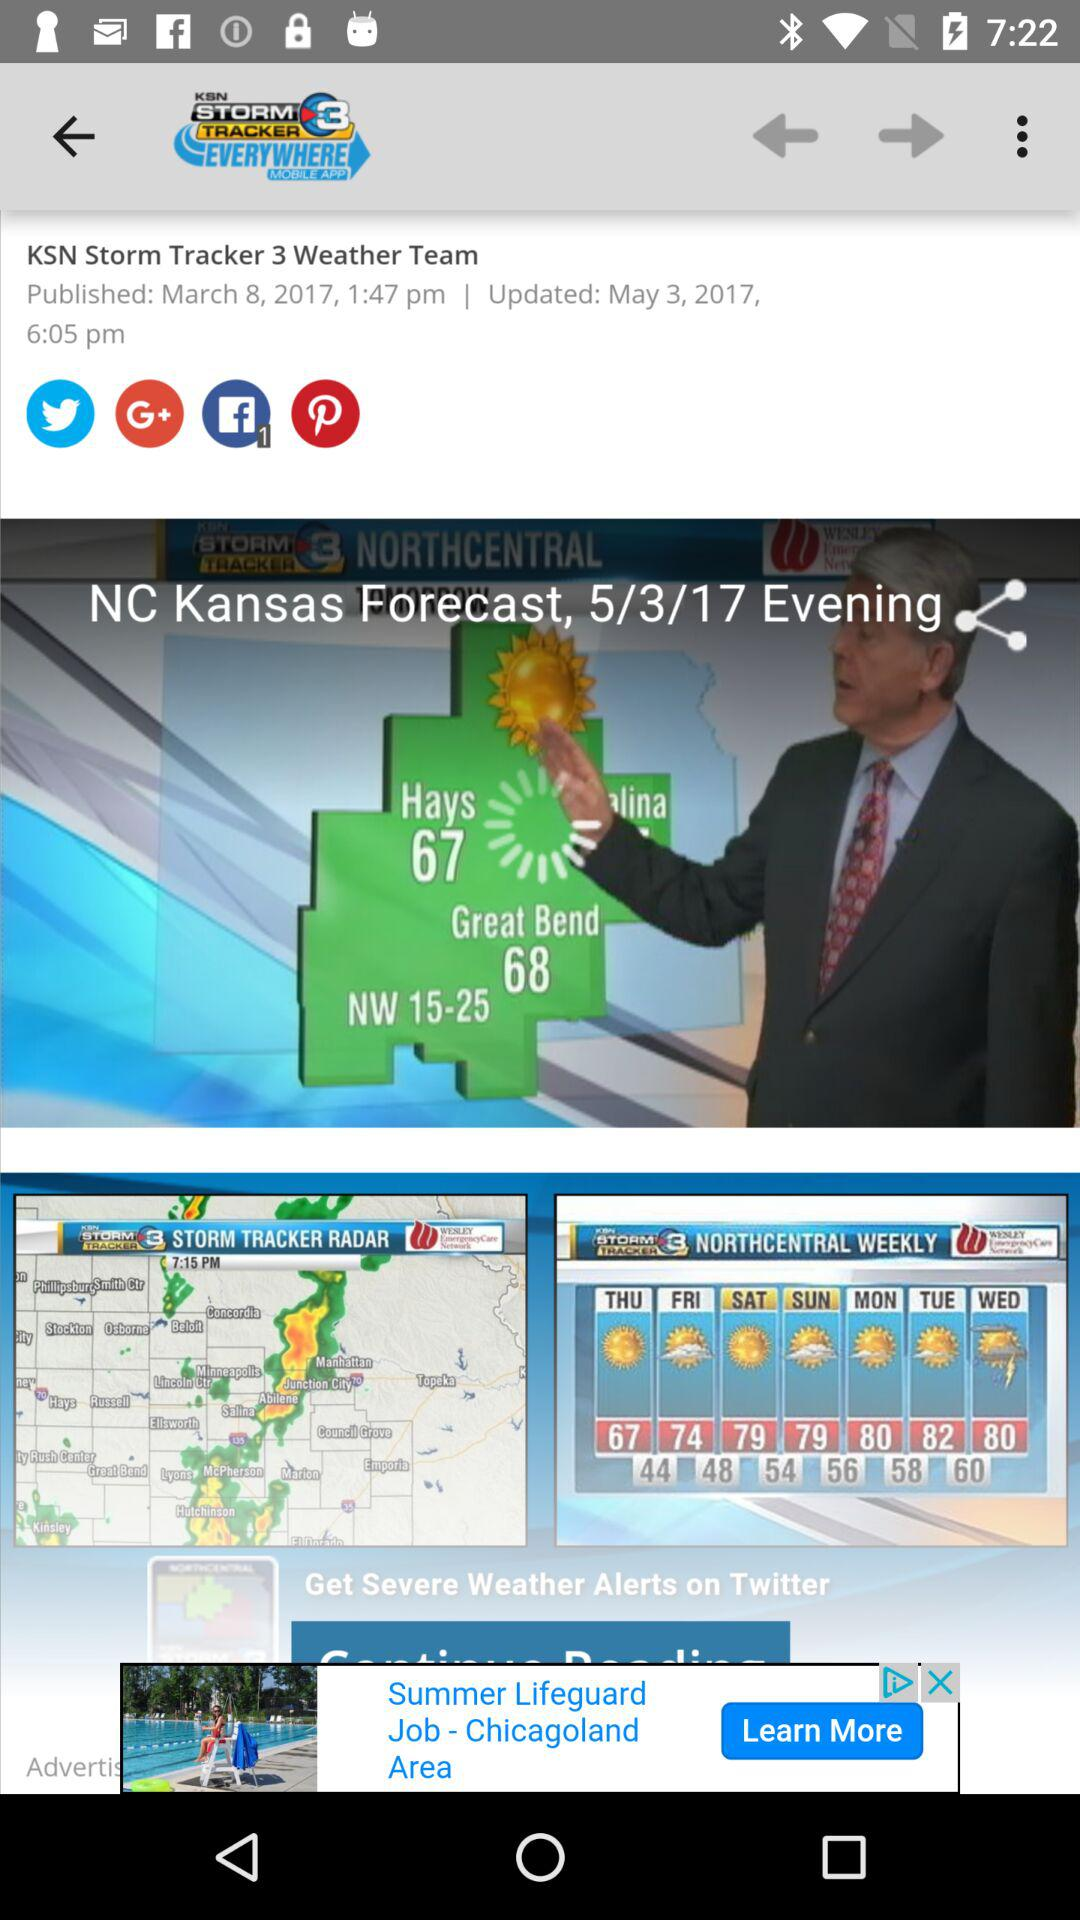What's the forecast location? The forecast location is Kansas. 